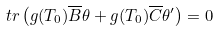Convert formula to latex. <formula><loc_0><loc_0><loc_500><loc_500>\ t r \left ( g ( T _ { 0 } ) \overline { B } \theta + g ( T _ { 0 } ) \overline { C } \theta ^ { \prime } \right ) = 0</formula> 